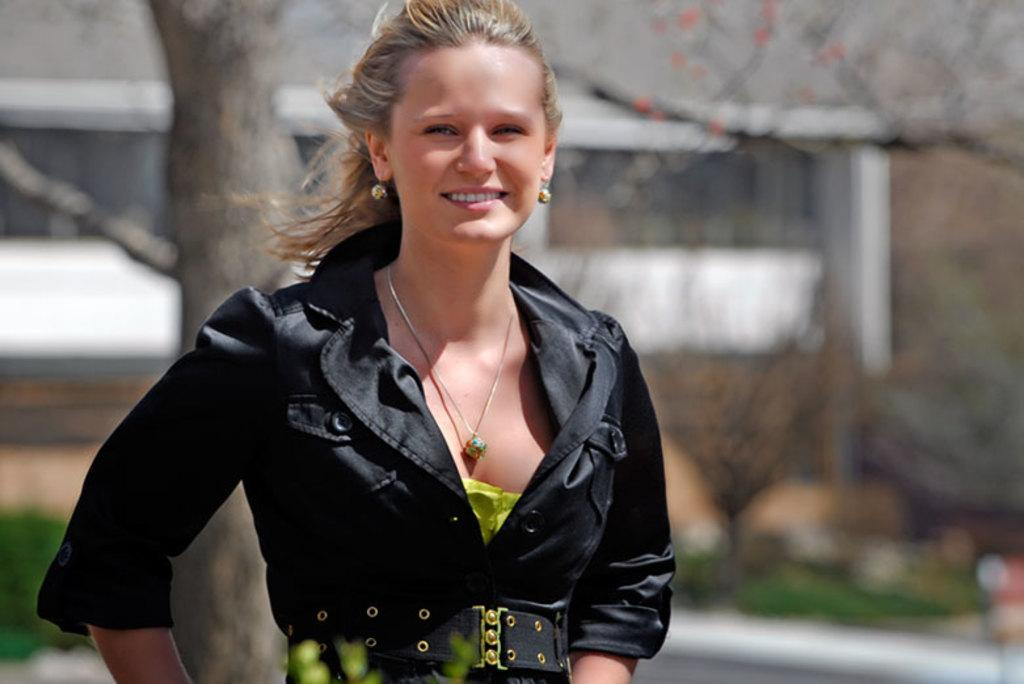Who or what is present in the image? There is a person in the image. What is the person wearing? The person is wearing a black and yellow dress. What can be seen in the background of the image? There are trees and a building in the background of the image. What type of brass instrument is the person playing in the image? There is no brass instrument present in the image; the person is simply wearing a black and yellow dress. Can you describe the beast that is accompanying the person in the image? There is no beast present in the image; only the person and the background elements are visible. 